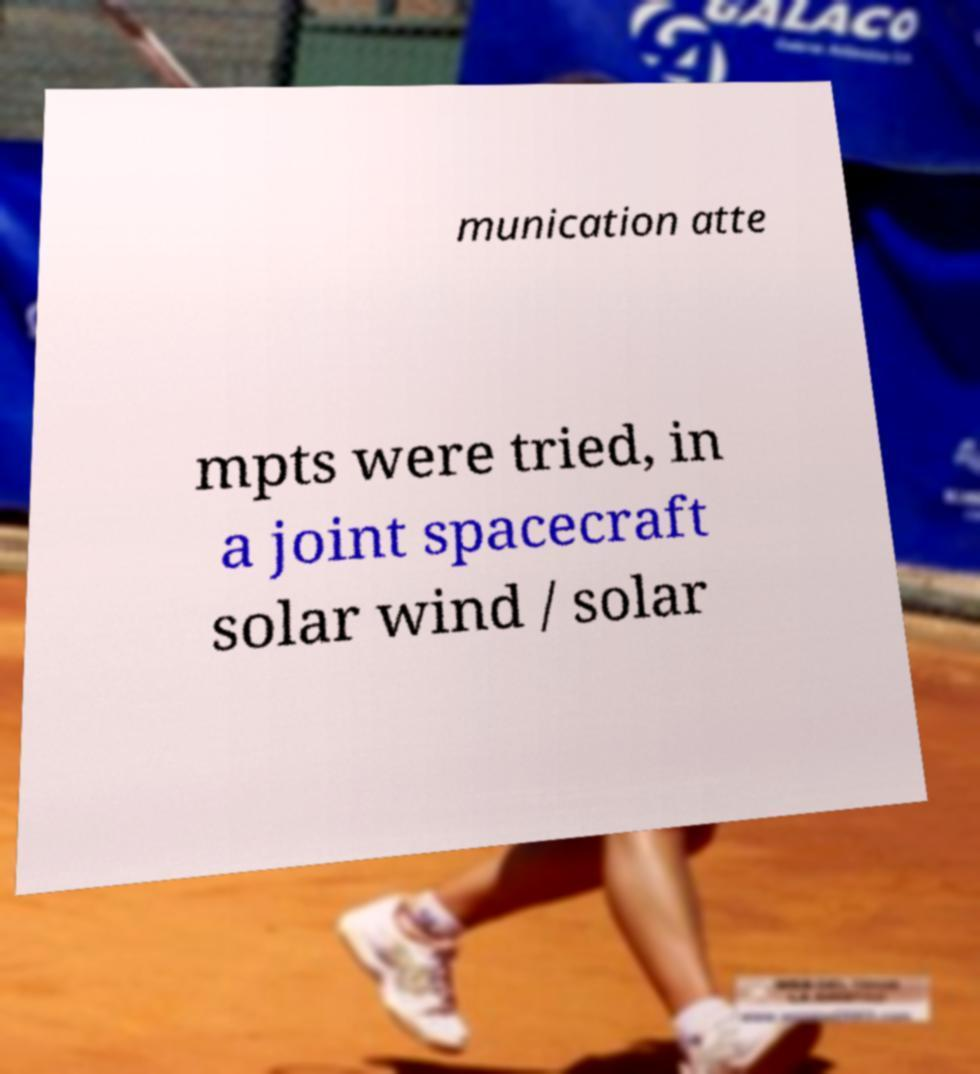Could you extract and type out the text from this image? munication atte mpts were tried, in a joint spacecraft solar wind / solar 